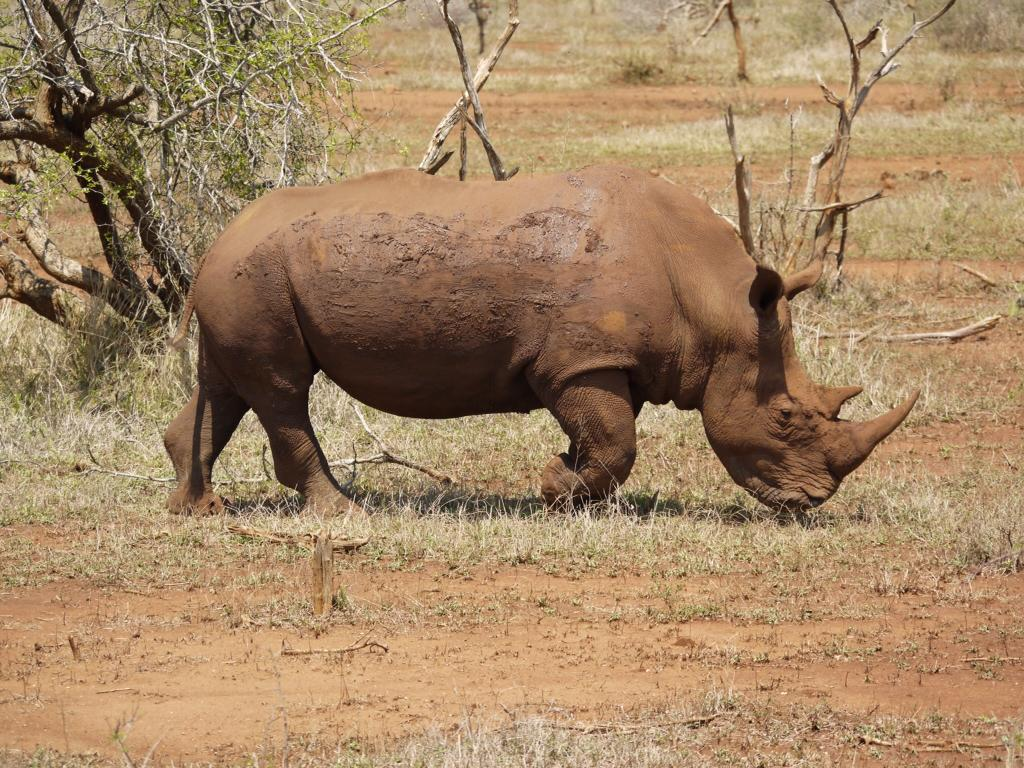What type of animal can be seen in the image? There is an animal in the image, but its specific type cannot be determined from the provided facts. What color is the animal in the image? The animal is brown in color. What is the animal's position in the image? The animal is standing on the ground. What can be seen in the background of the image? There are many trees visible in the background of the image. What type of stove can be seen in the image? There is no stove present in the image. Is the image taken during the night or day? The time of day cannot be determined from the provided facts. 